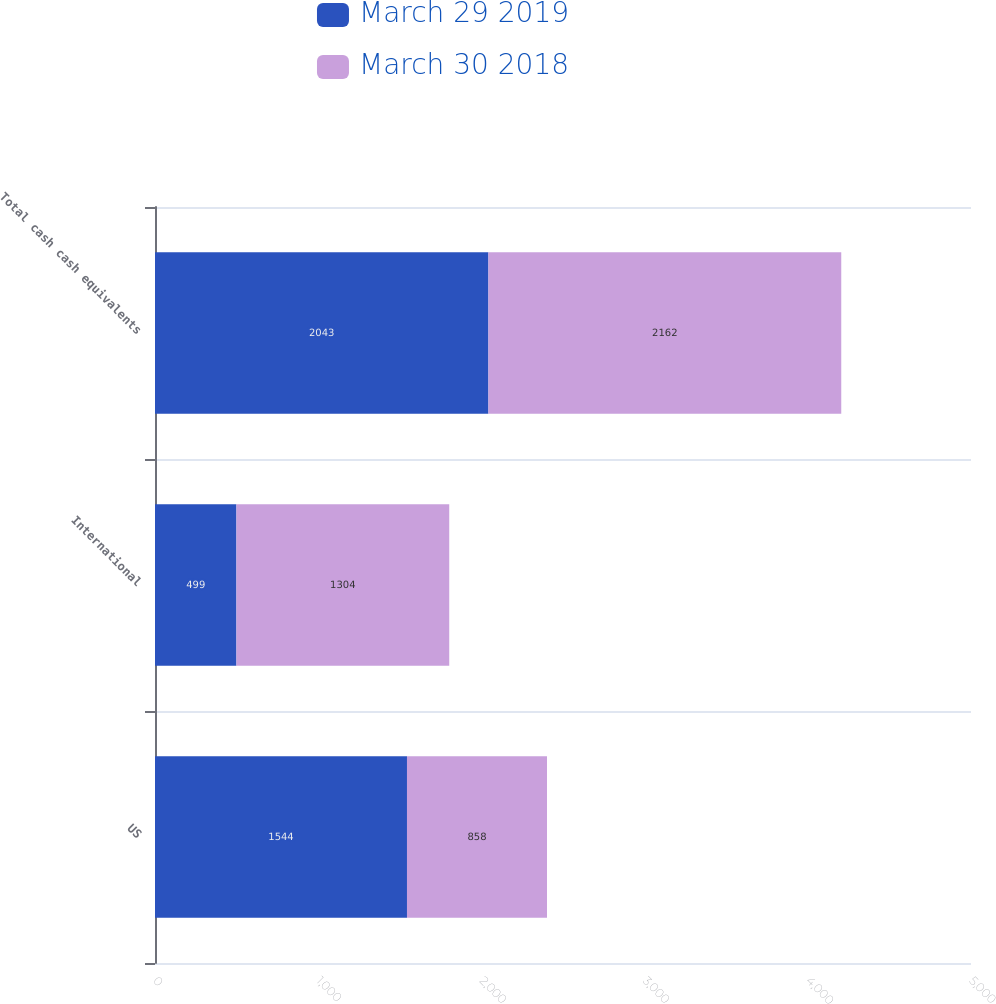Convert chart to OTSL. <chart><loc_0><loc_0><loc_500><loc_500><stacked_bar_chart><ecel><fcel>US<fcel>International<fcel>Total cash cash equivalents<nl><fcel>March 29 2019<fcel>1544<fcel>499<fcel>2043<nl><fcel>March 30 2018<fcel>858<fcel>1304<fcel>2162<nl></chart> 